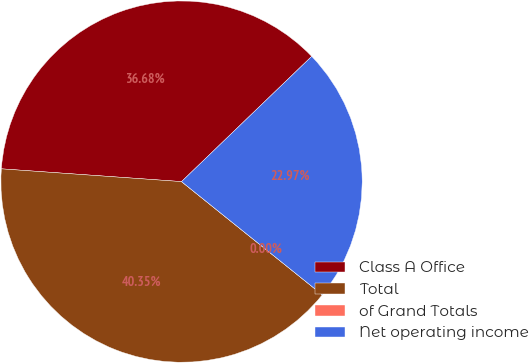Convert chart to OTSL. <chart><loc_0><loc_0><loc_500><loc_500><pie_chart><fcel>Class A Office<fcel>Total<fcel>of Grand Totals<fcel>Net operating income<nl><fcel>36.68%<fcel>40.35%<fcel>0.0%<fcel>22.97%<nl></chart> 